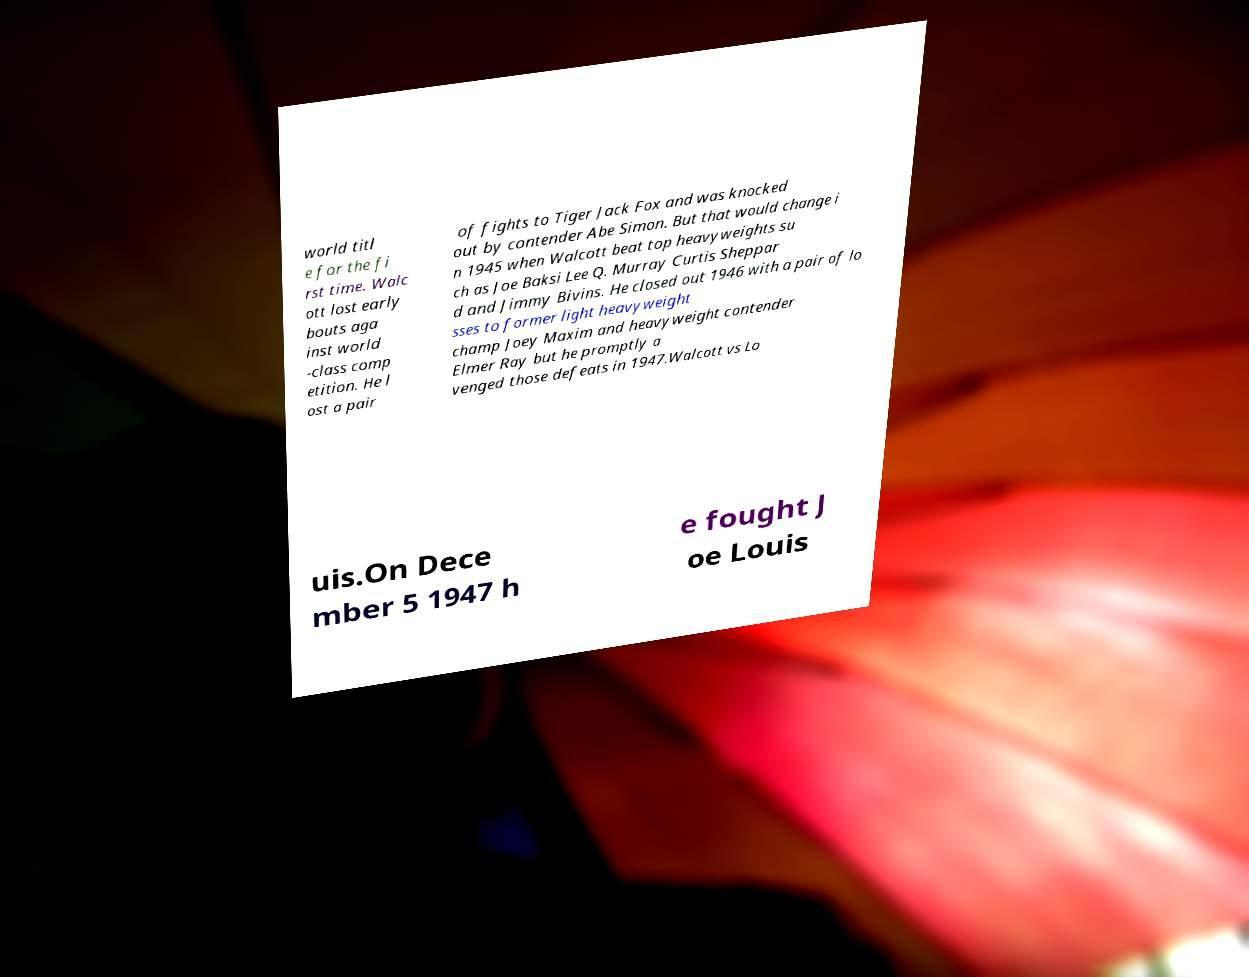Please read and relay the text visible in this image. What does it say? world titl e for the fi rst time. Walc ott lost early bouts aga inst world -class comp etition. He l ost a pair of fights to Tiger Jack Fox and was knocked out by contender Abe Simon. But that would change i n 1945 when Walcott beat top heavyweights su ch as Joe Baksi Lee Q. Murray Curtis Sheppar d and Jimmy Bivins. He closed out 1946 with a pair of lo sses to former light heavyweight champ Joey Maxim and heavyweight contender Elmer Ray but he promptly a venged those defeats in 1947.Walcott vs Lo uis.On Dece mber 5 1947 h e fought J oe Louis 